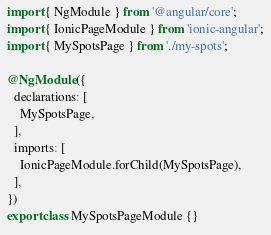Convert code to text. <code><loc_0><loc_0><loc_500><loc_500><_TypeScript_>import { NgModule } from '@angular/core';
import { IonicPageModule } from 'ionic-angular';
import { MySpotsPage } from './my-spots';

@NgModule({
  declarations: [
    MySpotsPage,
  ],
  imports: [
    IonicPageModule.forChild(MySpotsPage),
  ],
})
export class MySpotsPageModule {}
</code> 